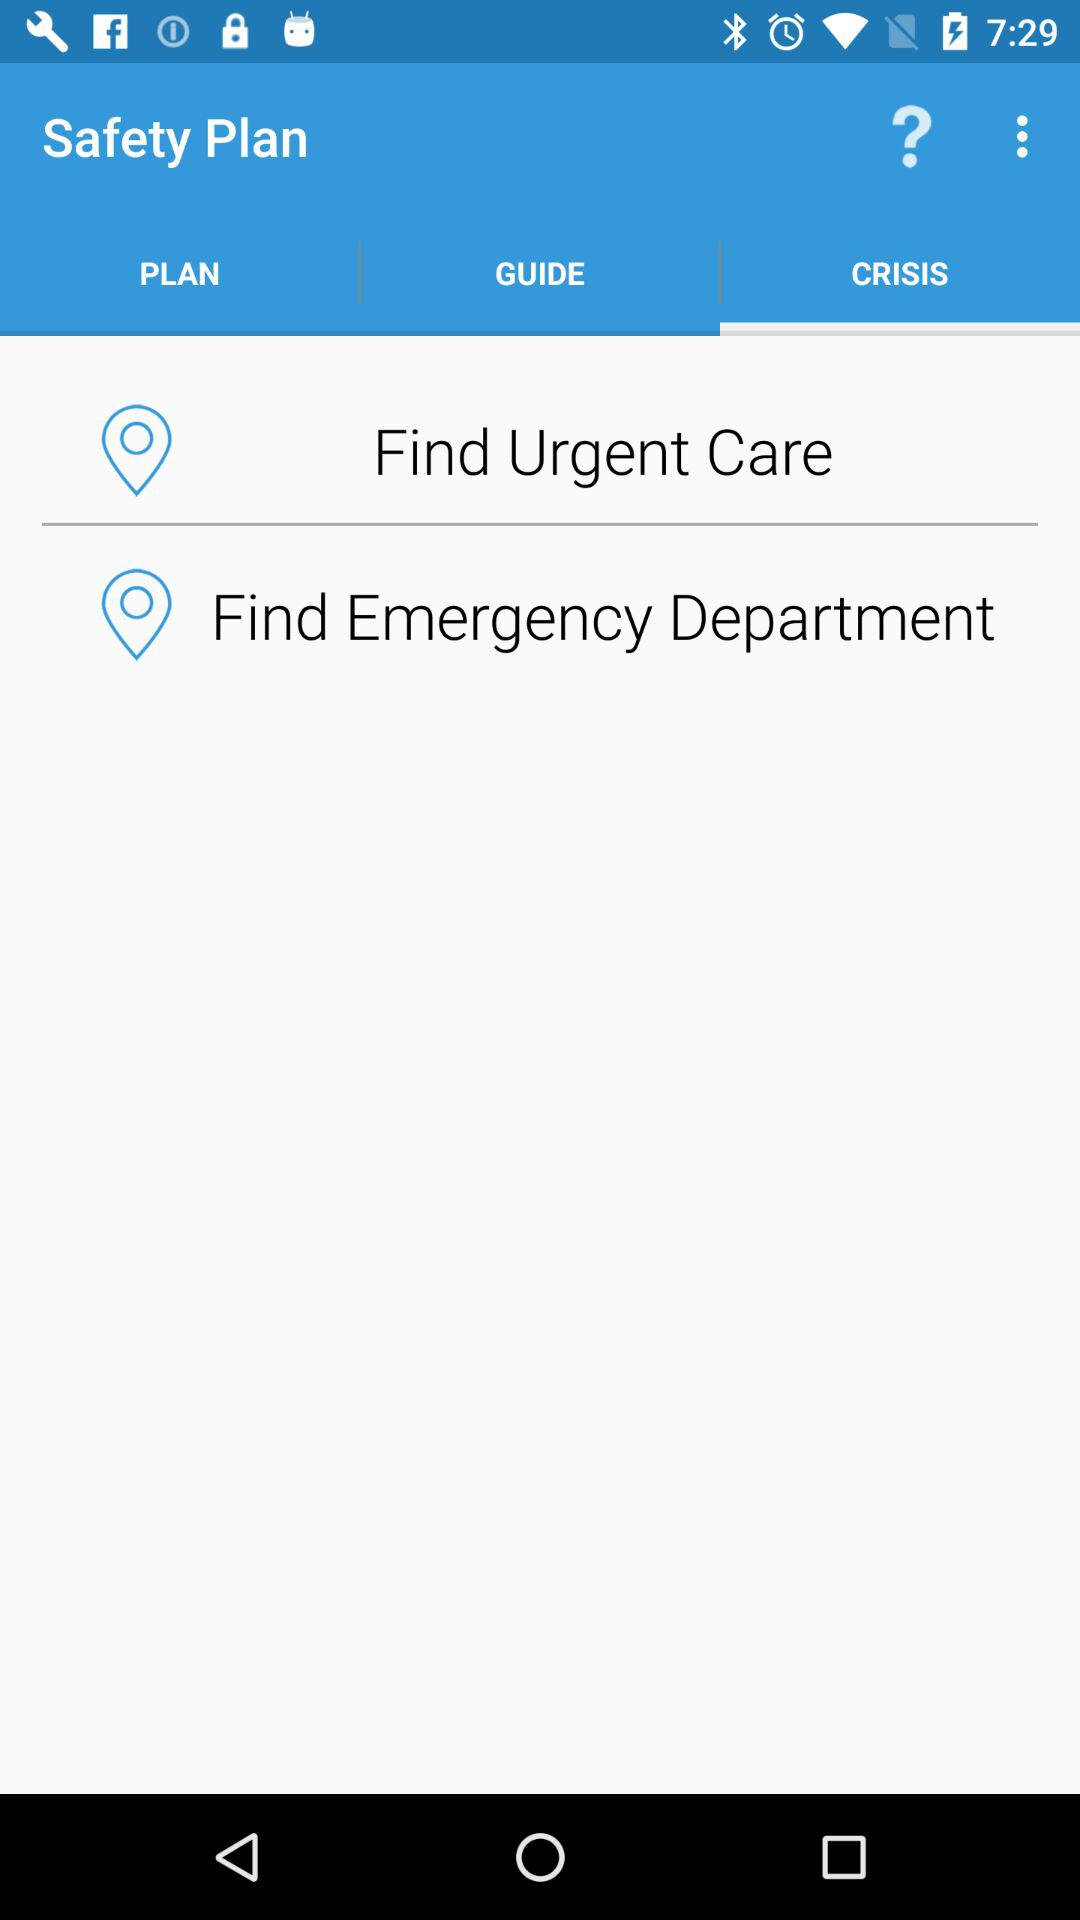Which option is selected in "Safety Plan"? The selected option is "CRISIS". 